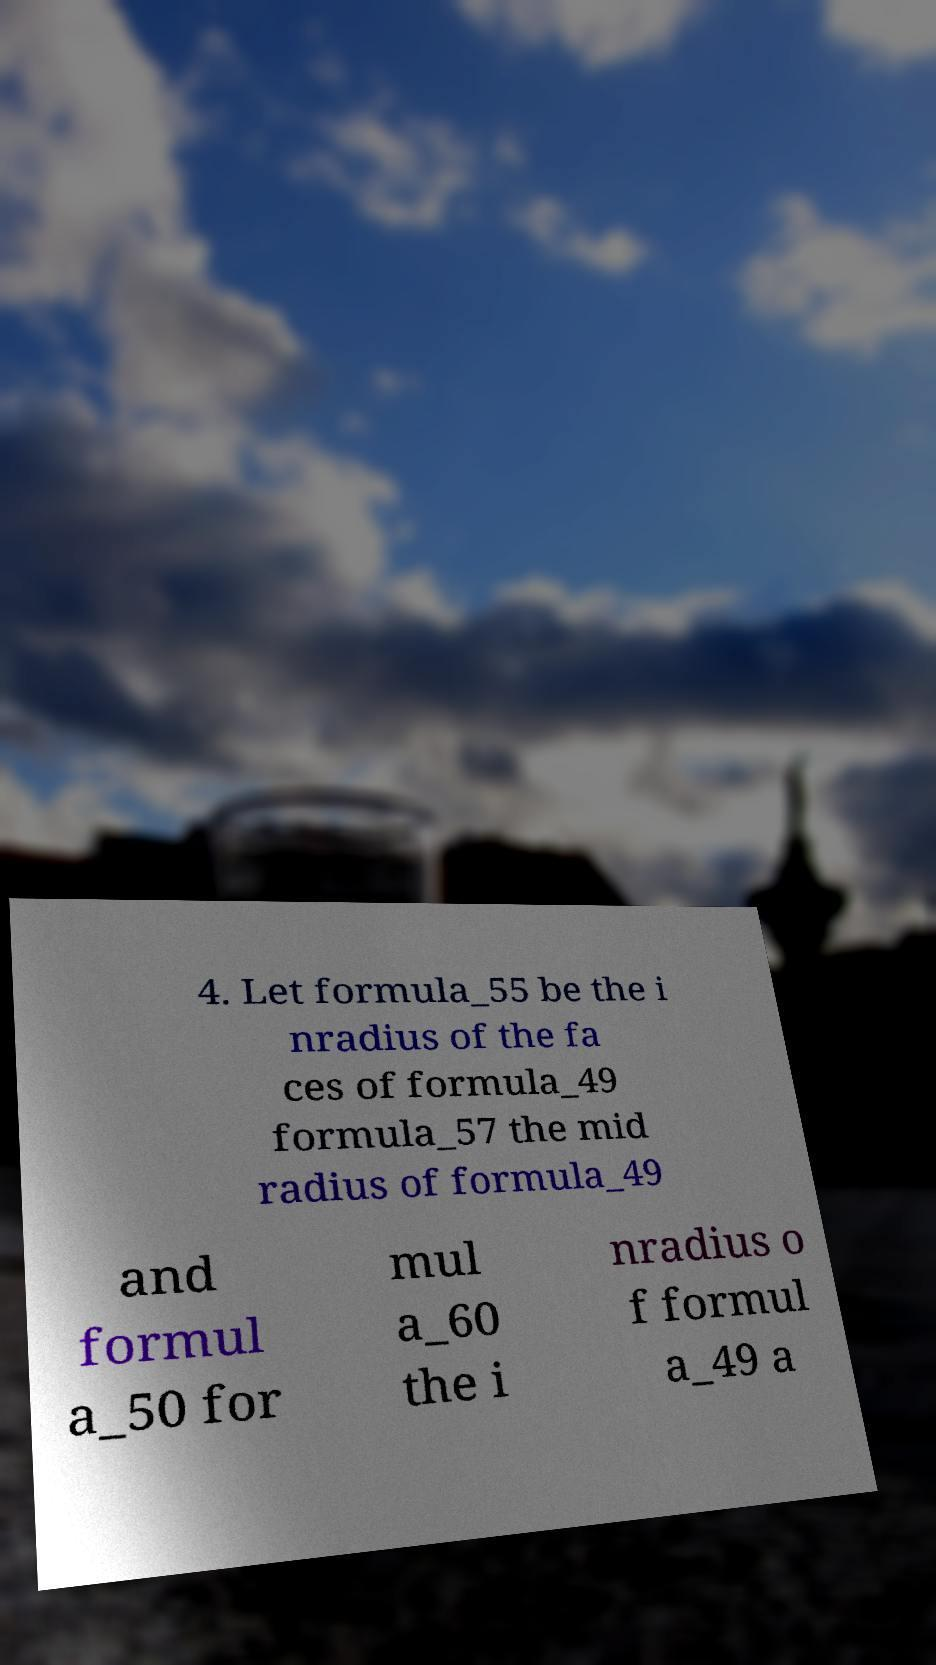Could you extract and type out the text from this image? 4. Let formula_55 be the i nradius of the fa ces of formula_49 formula_57 the mid radius of formula_49 and formul a_50 for mul a_60 the i nradius o f formul a_49 a 